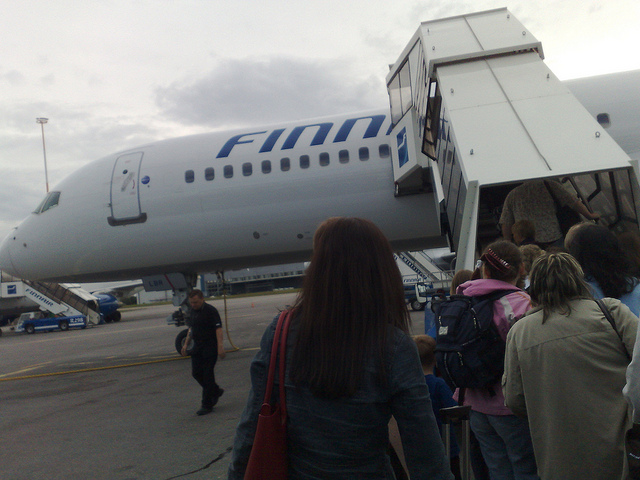<image>What type of haircut does the girl with the red purse have? I'm not sure about the type of haircut the girl with the red purse has. It could be long. What type of haircut does the girl with the red purse have? I don't know what type of haircut the girl with the red purse has. It can be long or below shoulder. 